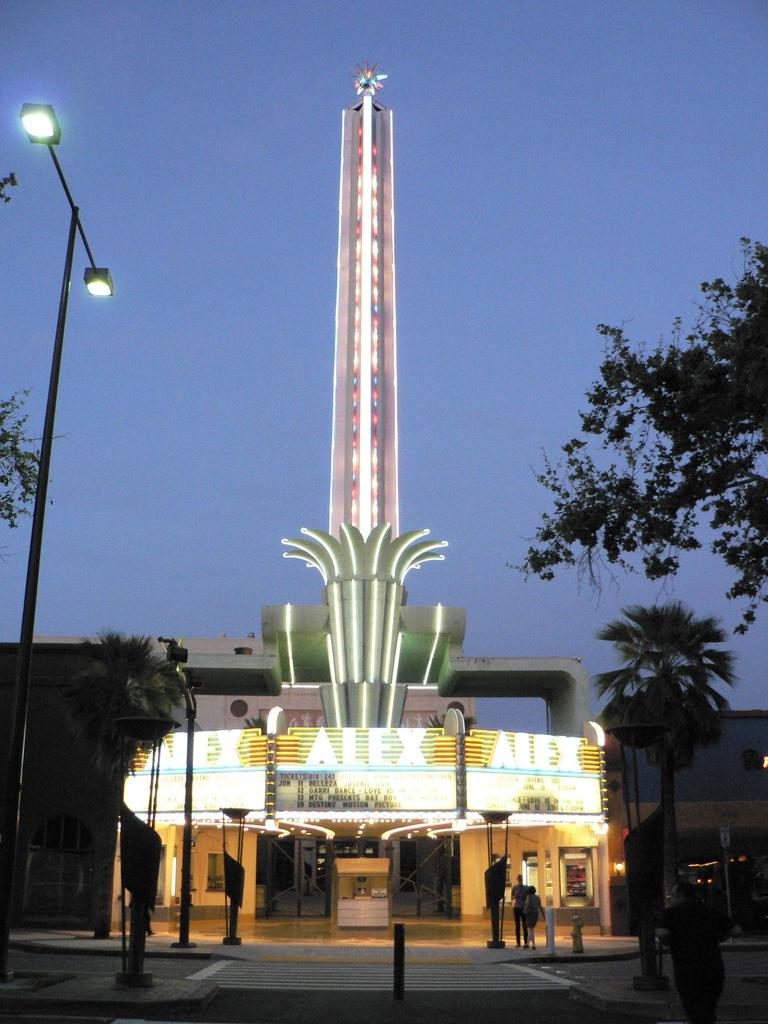What type of structure is present in the image? There is a building-like place in the image. Are there any additional features near the building? Yes, there are lights near the building. What else can be seen in the image? There are poles, trees, and people in the image. Can you see any drains in the image? There is no mention of drains in the provided facts, so we cannot determine if any are present in the image. 